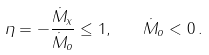Convert formula to latex. <formula><loc_0><loc_0><loc_500><loc_500>\eta = - \frac { \dot { M } _ { x } } { \dot { M } _ { o } } \leq 1 , \quad \dot { M } _ { o } < 0 \, .</formula> 